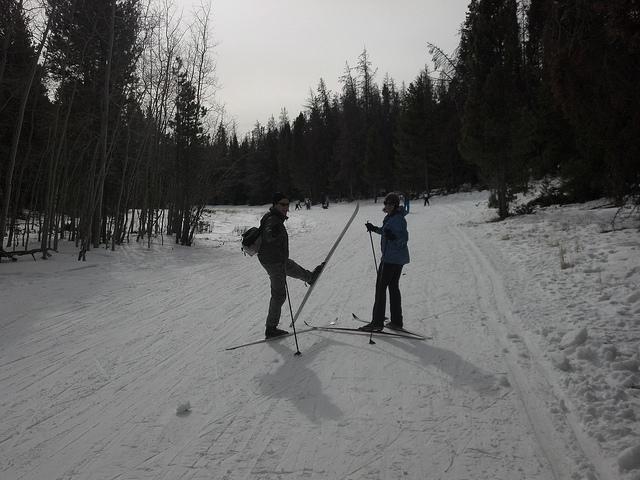How steep is the slope?
Write a very short answer. Not at all. Do these people appear to be heading to work?
Write a very short answer. No. Is the sun being reflected off the snow?
Short answer required. No. Do the trees have snow on them?
Keep it brief. No. Is there a dog here?
Answer briefly. No. Are the trees in the far background deciduous or coniferous?
Be succinct. Coniferous. Are there shadows on the ground?
Short answer required. Yes. Is there an overcast in the sky?
Write a very short answer. Yes. 